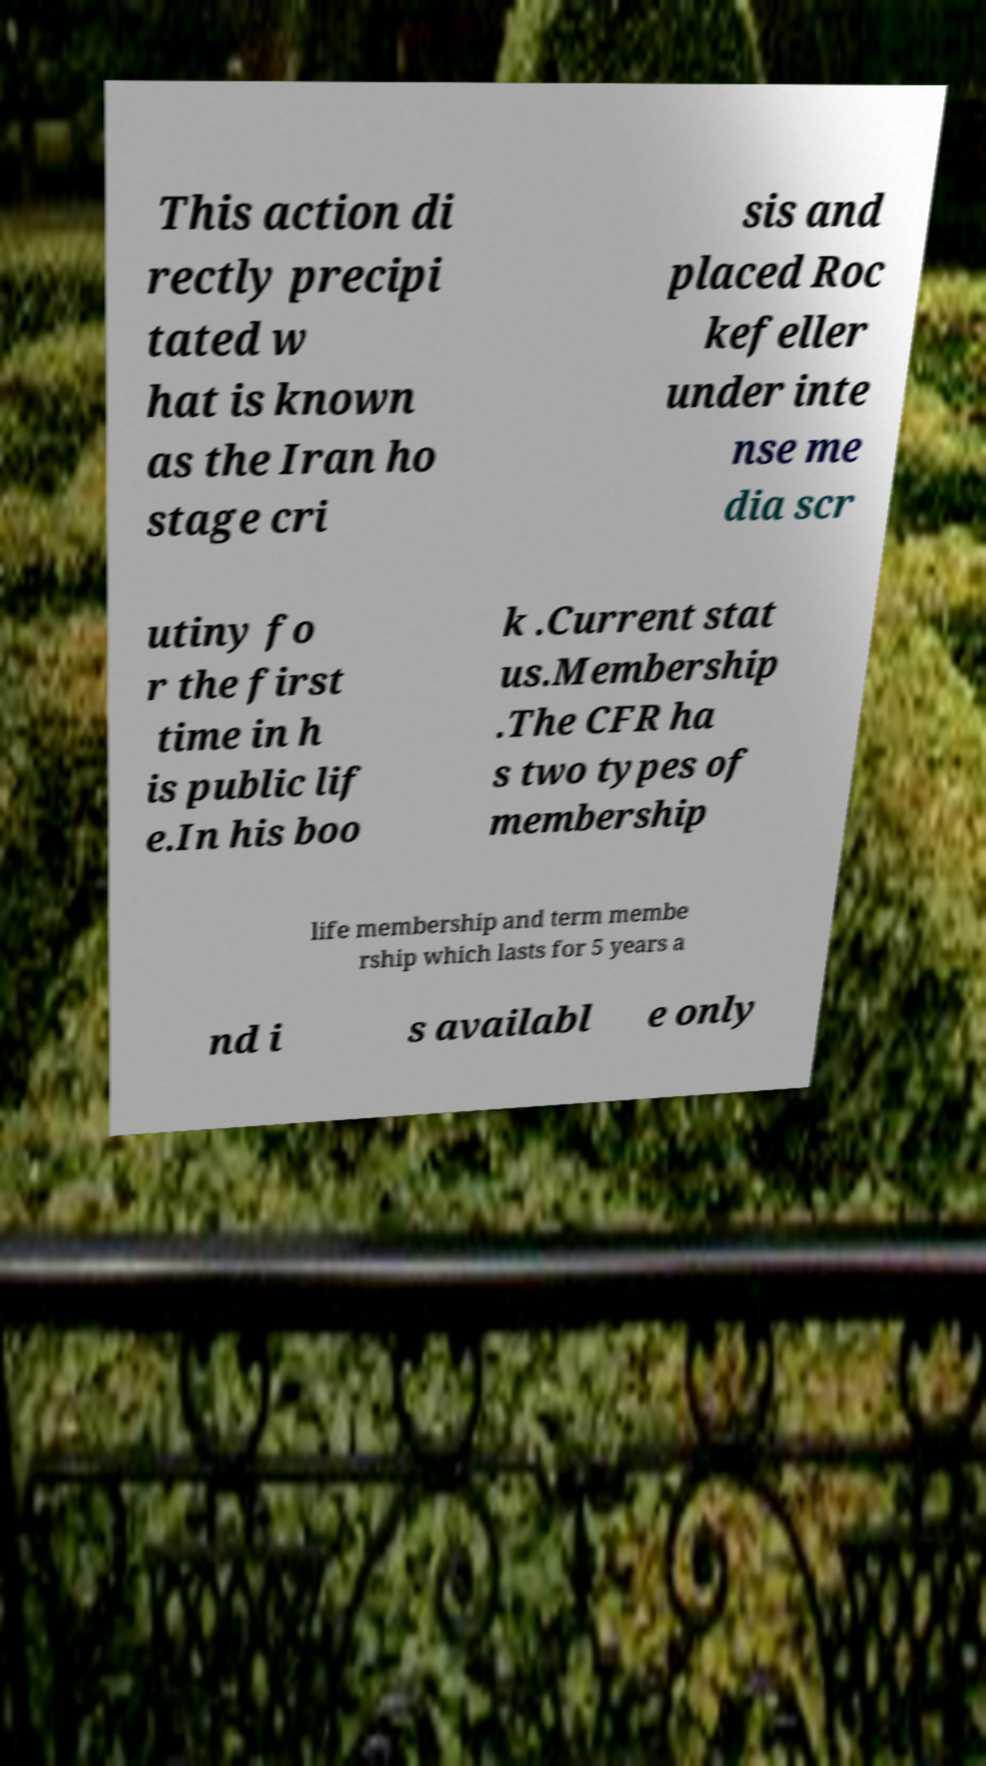Can you accurately transcribe the text from the provided image for me? This action di rectly precipi tated w hat is known as the Iran ho stage cri sis and placed Roc kefeller under inte nse me dia scr utiny fo r the first time in h is public lif e.In his boo k .Current stat us.Membership .The CFR ha s two types of membership life membership and term membe rship which lasts for 5 years a nd i s availabl e only 